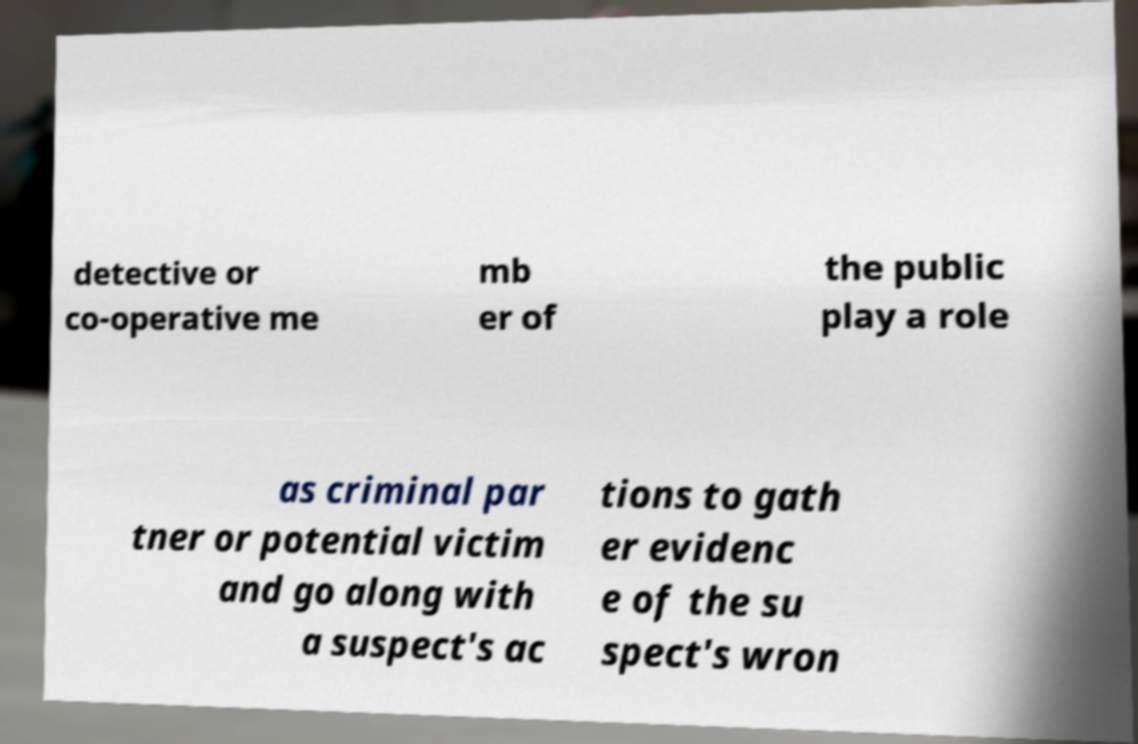Please identify and transcribe the text found in this image. detective or co-operative me mb er of the public play a role as criminal par tner or potential victim and go along with a suspect's ac tions to gath er evidenc e of the su spect's wron 